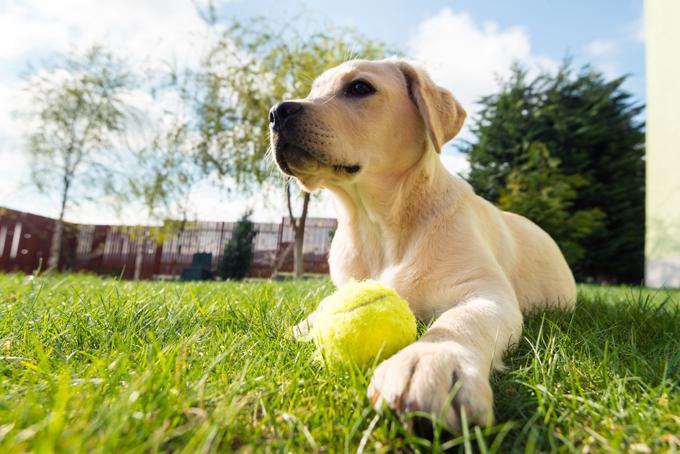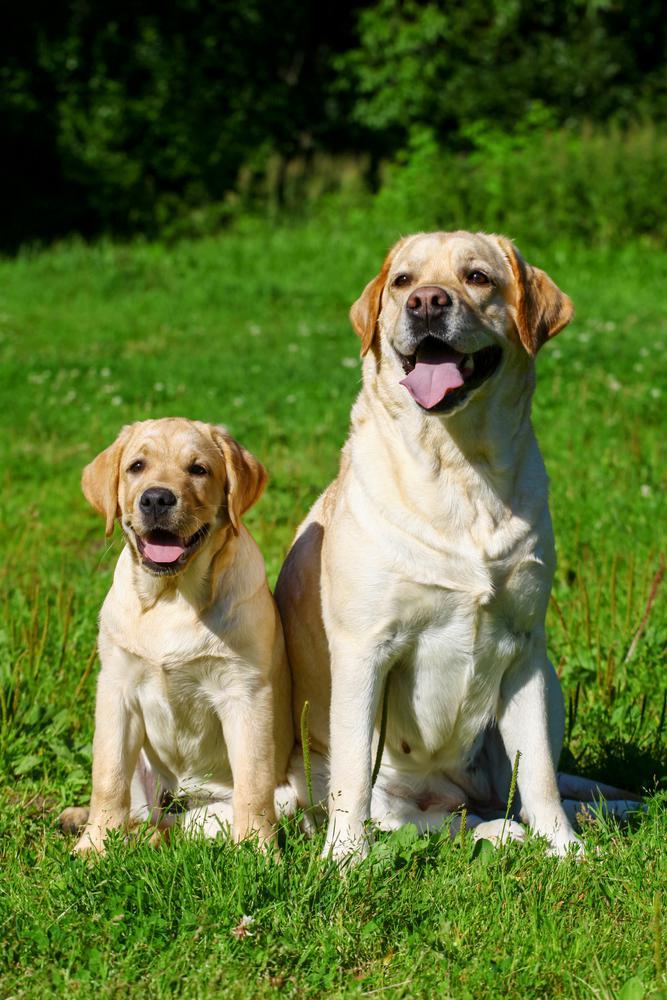The first image is the image on the left, the second image is the image on the right. For the images displayed, is the sentence "There are more dogs in the left image than in the right." factually correct? Answer yes or no. No. The first image is the image on the left, the second image is the image on the right. For the images displayed, is the sentence "At least four dogs in a grassy area have their mouths open and their tongues showing." factually correct? Answer yes or no. No. 